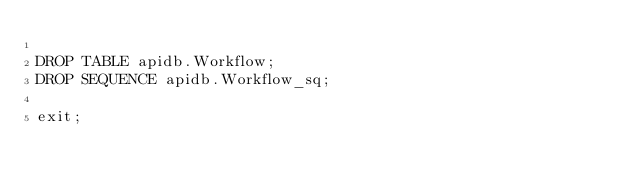<code> <loc_0><loc_0><loc_500><loc_500><_SQL_>
DROP TABLE apidb.Workflow;
DROP SEQUENCE apidb.Workflow_sq;
 
exit;
</code> 